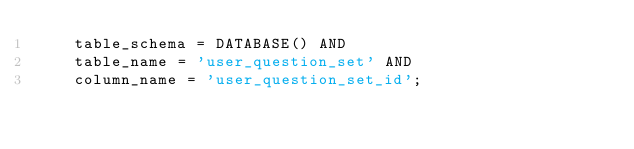Convert code to text. <code><loc_0><loc_0><loc_500><loc_500><_SQL_>    table_schema = DATABASE() AND
    table_name = 'user_question_set' AND
    column_name = 'user_question_set_id';
</code> 